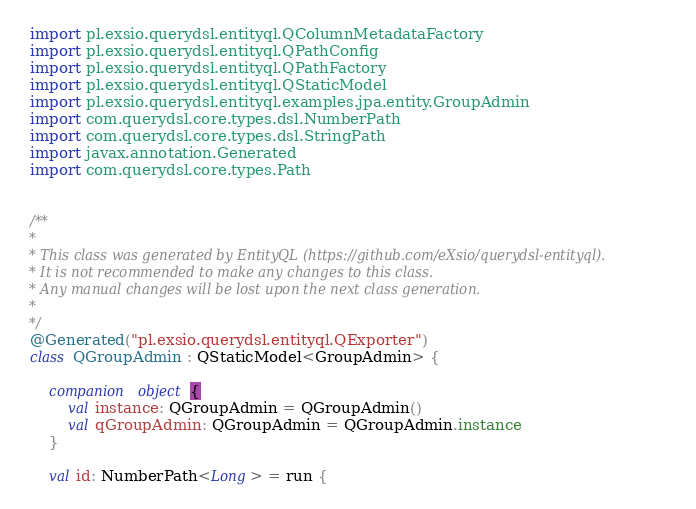<code> <loc_0><loc_0><loc_500><loc_500><_Kotlin_> import pl.exsio.querydsl.entityql.QColumnMetadataFactory
 import pl.exsio.querydsl.entityql.QPathConfig
 import pl.exsio.querydsl.entityql.QPathFactory
 import pl.exsio.querydsl.entityql.QStaticModel
 import pl.exsio.querydsl.entityql.examples.jpa.entity.GroupAdmin
 import com.querydsl.core.types.dsl.NumberPath
 import com.querydsl.core.types.dsl.StringPath
 import javax.annotation.Generated
 import com.querydsl.core.types.Path
 

 /**
 *
 * This class was generated by EntityQL (https://github.com/eXsio/querydsl-entityql).
 * It is not recommended to make any changes to this class.
 * Any manual changes will be lost upon the next class generation.
 *
 */
 @Generated("pl.exsio.querydsl.entityql.QExporter")
 class QGroupAdmin : QStaticModel<GroupAdmin> {

     companion object {
         val instance: QGroupAdmin = QGroupAdmin()
         val qGroupAdmin: QGroupAdmin = QGroupAdmin.instance
     }

     val id: NumberPath<Long> = run {</code> 